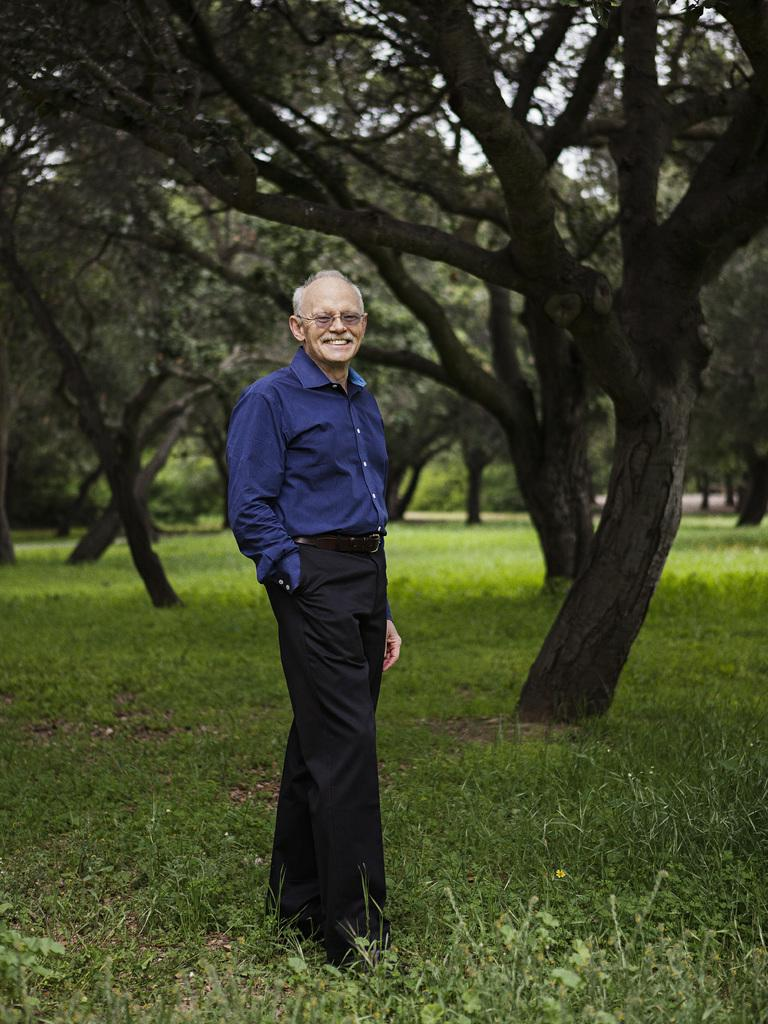What is the man in the image doing? The man is standing in the image. What is the man's facial expression? The man is smiling. What type of clothing is the man wearing? The man is wearing a shirt, trousers, and shoes. What accessory is the man wearing? The man is wearing spectacles. What type of vegetation can be seen in the image? There are trees with branches and leaves in the image. What type of ground cover is visible in the image? There is grass visible in the image. What type of science experiment is being conducted in the image? There is no science experiment present in the image; it features a man standing and smiling. What type of blade is being used to cut the grass in the image? There is no blade visible in the image, as the grass is not being cut. 